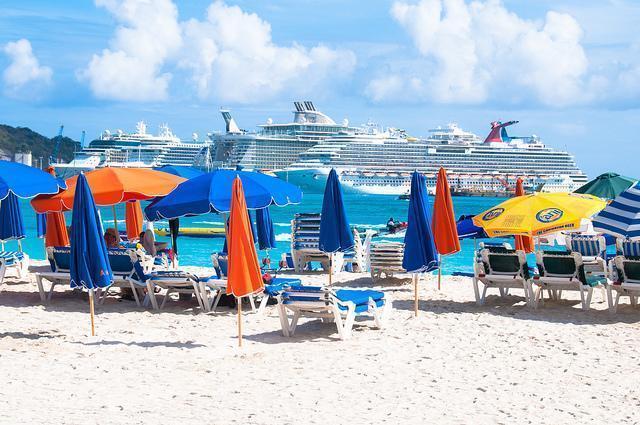What kind of ship is the one in the water?
Make your selection from the four choices given to correctly answer the question.
Options: Container, naval, passenger, tanker. Passenger. 